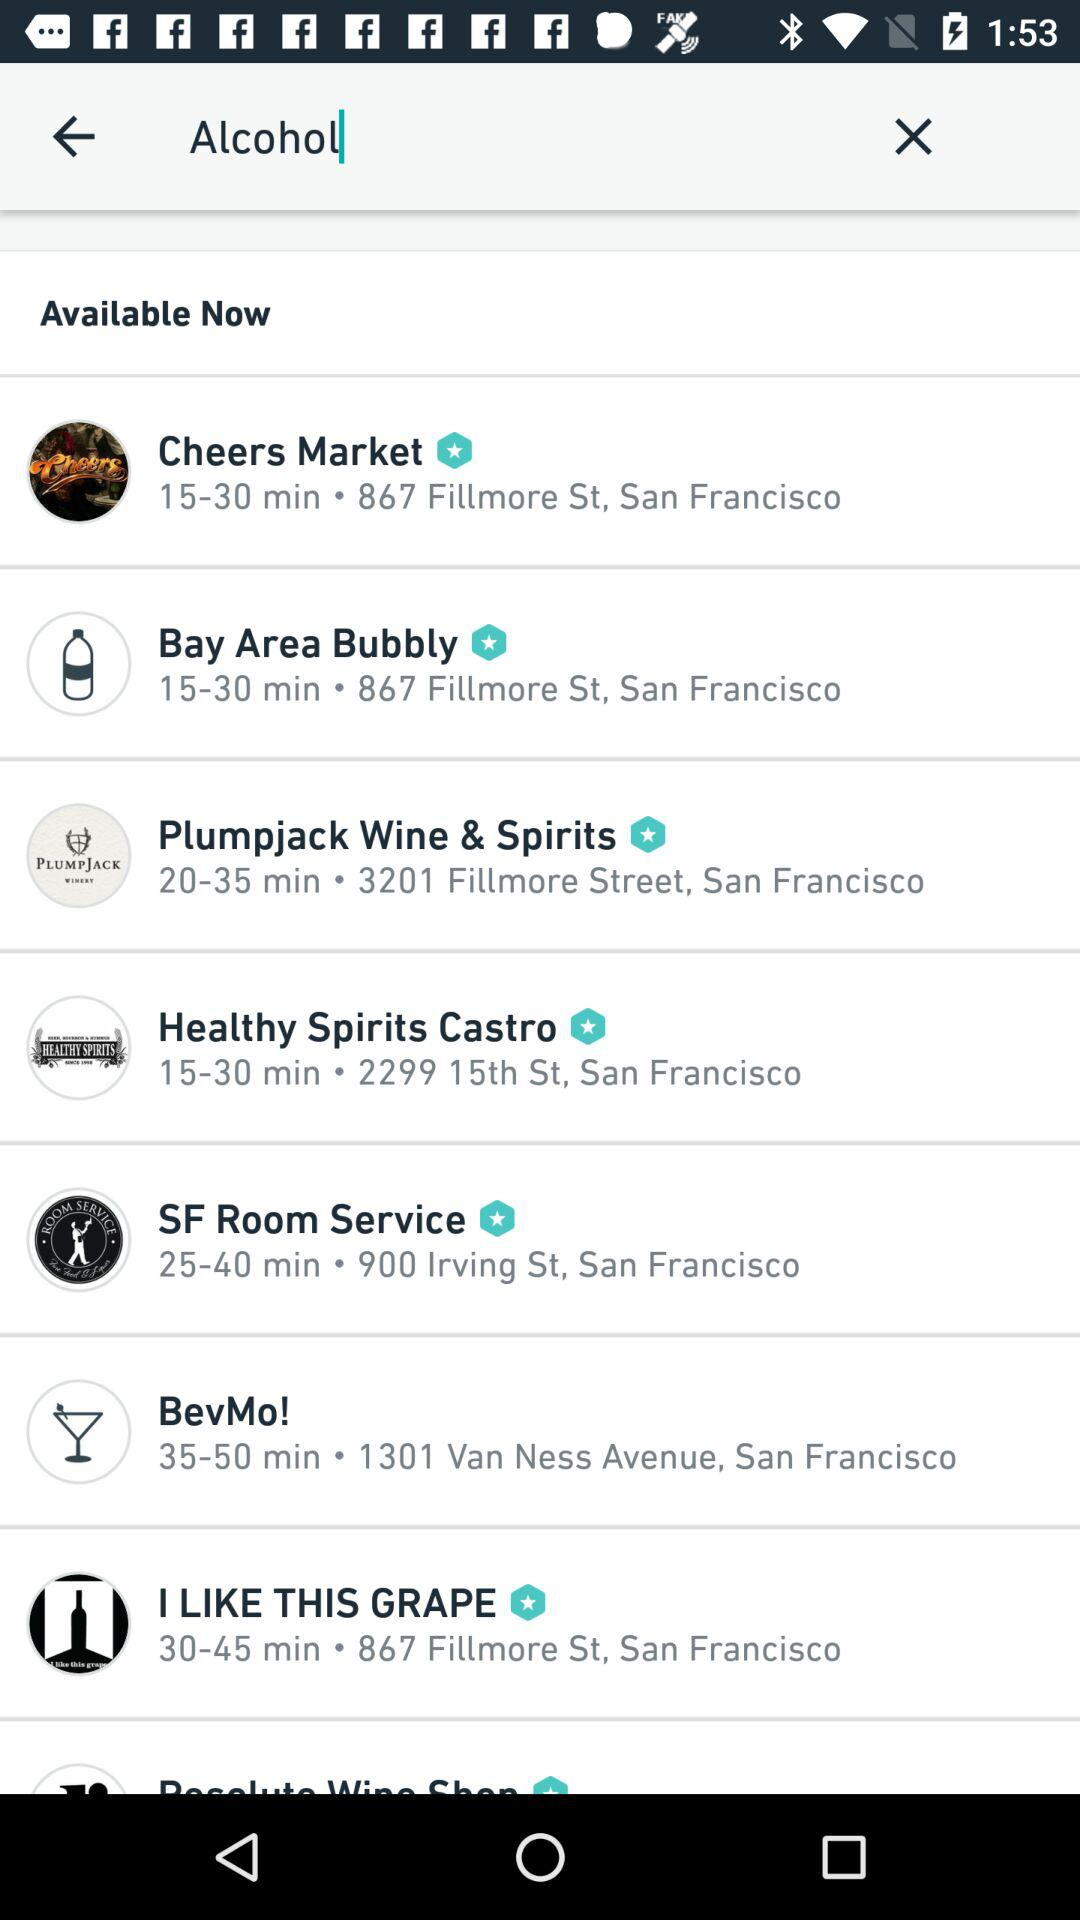How far is the Plumpjack Wine & Spirits?
When the provided information is insufficient, respond with <no answer>. <no answer> 